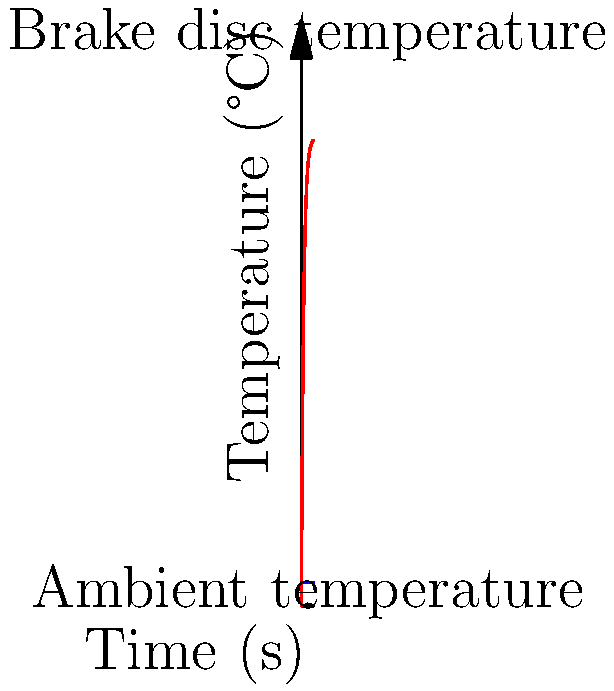A race car's brake disc temperature rises rapidly during repeated high-speed braking. The graph shows the temperature increase of the brake disc over time. If the initial temperature of the disc is 20°C and it follows the equation $T(t) = 400(1-e^{-0.5t}) + 20$, where $T$ is temperature in °C and $t$ is time in seconds, what is the maximum temperature the brake disc will reach as $t$ approaches infinity? Let's approach this step-by-step:

1) The given equation is $T(t) = 400(1-e^{-0.5t}) + 20$

2) To find the maximum temperature as $t$ approaches infinity, we need to evaluate the limit:
   
   $\lim_{t \to \infty} T(t) = \lim_{t \to \infty} [400(1-e^{-0.5t}) + 20]$

3) As $t$ approaches infinity, $e^{-0.5t}$ approaches 0:
   
   $\lim_{t \to \infty} e^{-0.5t} = 0$

4) Therefore:
   
   $\lim_{t \to \infty} T(t) = 400(1-0) + 20 = 400 + 20 = 420$

5) The maximum temperature the brake disc will reach is 420°C.

This makes sense physically: the brake disc temperature rises rapidly at first, then slows down as it approaches the maximum temperature, creating an asymptotic curve as seen in the graph.
Answer: 420°C 